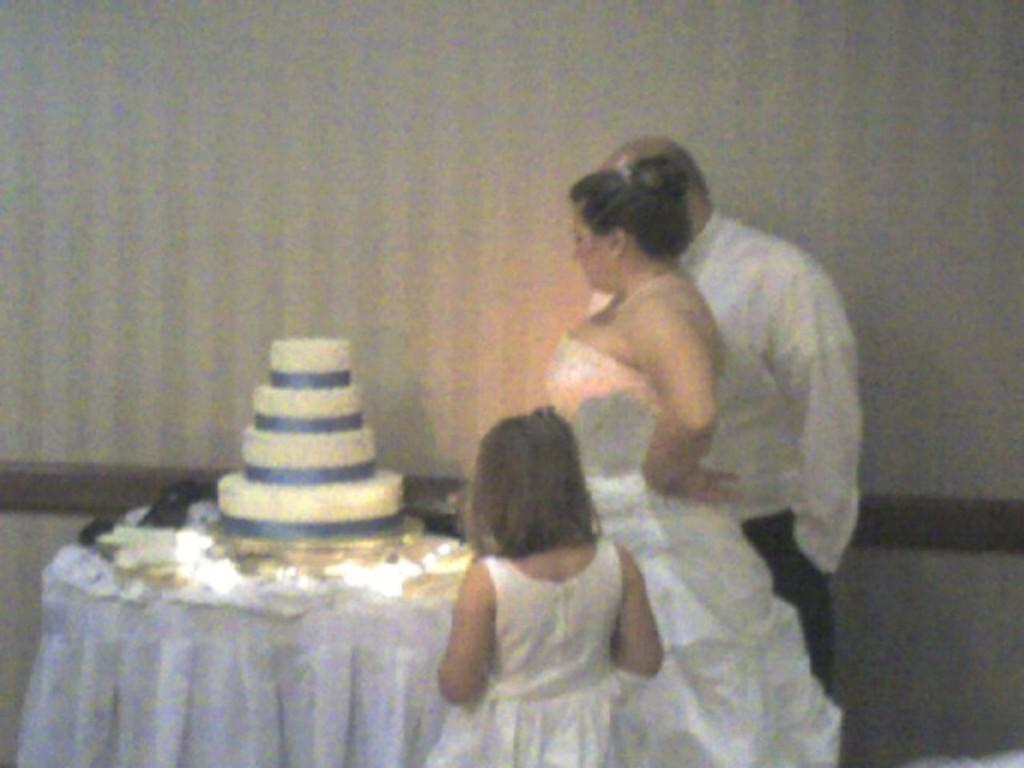How many people are in the image? There are three people in the image. What are the people doing in the image? The people are standing. What colors are the people wearing in the image? The people are wearing white and black color dresses. What is the main food item visible in the image? There is a cake in the image. What is on the table in the image? There are objects on a table in the image. What is the color of the wall in the image? There is a white wall in the image. What type of question is being asked by the cake in the image? There is no indication in the image that the cake is asking a question or capable of doing so. 